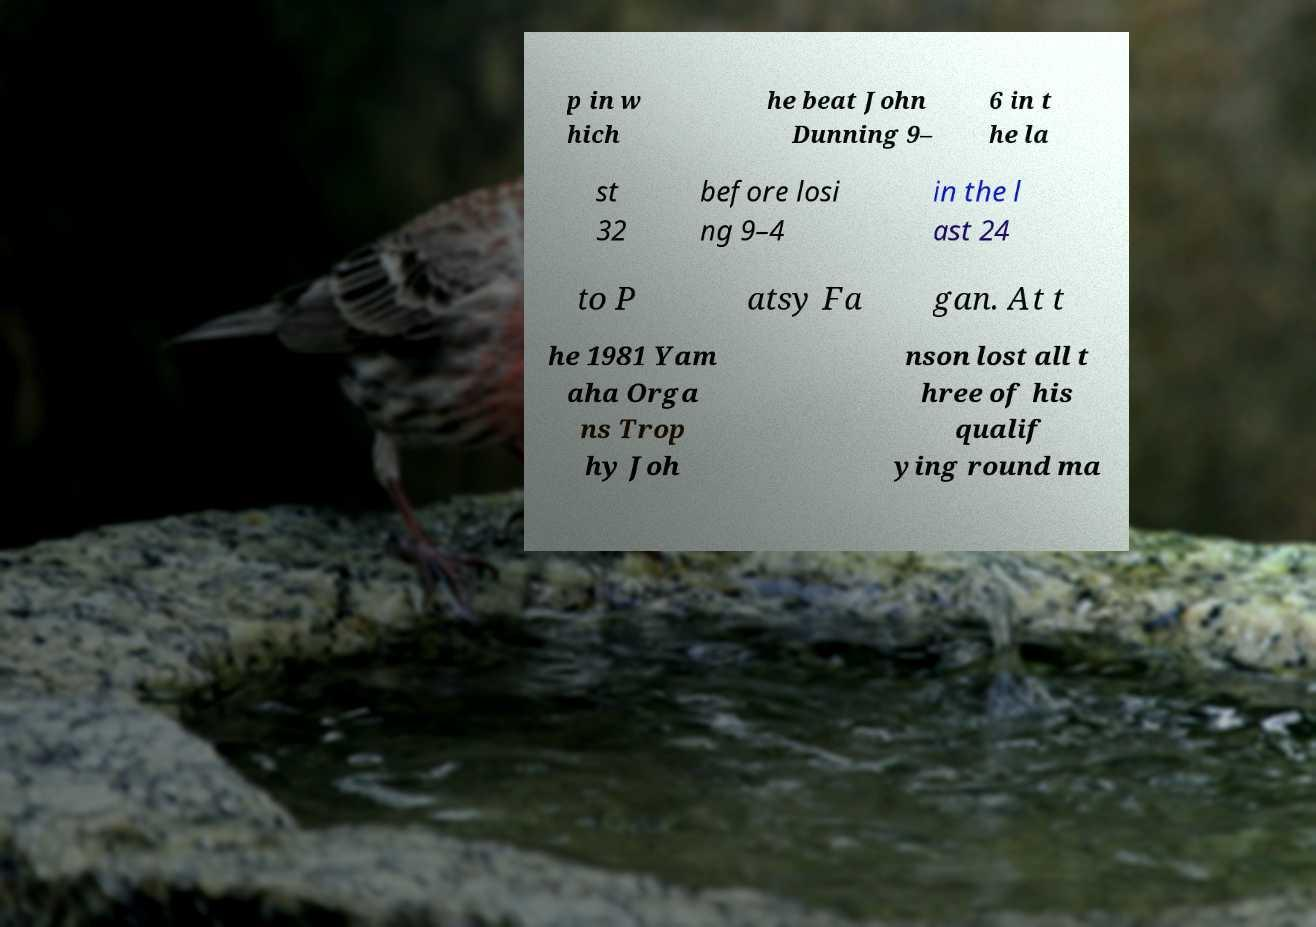Can you read and provide the text displayed in the image?This photo seems to have some interesting text. Can you extract and type it out for me? p in w hich he beat John Dunning 9– 6 in t he la st 32 before losi ng 9–4 in the l ast 24 to P atsy Fa gan. At t he 1981 Yam aha Orga ns Trop hy Joh nson lost all t hree of his qualif ying round ma 